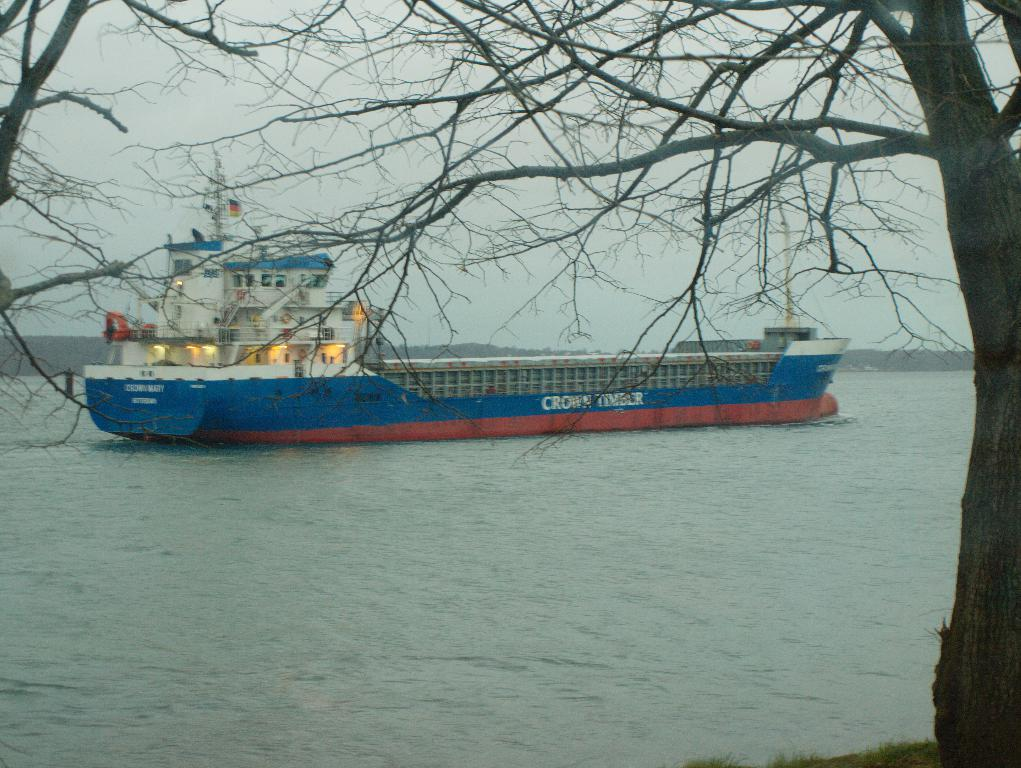What is the main subject of the image? The main subject of the image is a ship in the water. What features can be seen on the ship? There is a light and a flag on the ship. What is located in front of the ship? There is a tree in front of the ship. What can be seen in the background of the image? There are mountains in the background. What is visible at the top of the image? The sky is visible at the top of the image. What type of badge is the animal wearing in the image? There is no animal present in the image, and therefore no badge or any interaction with an animal can be observed. 